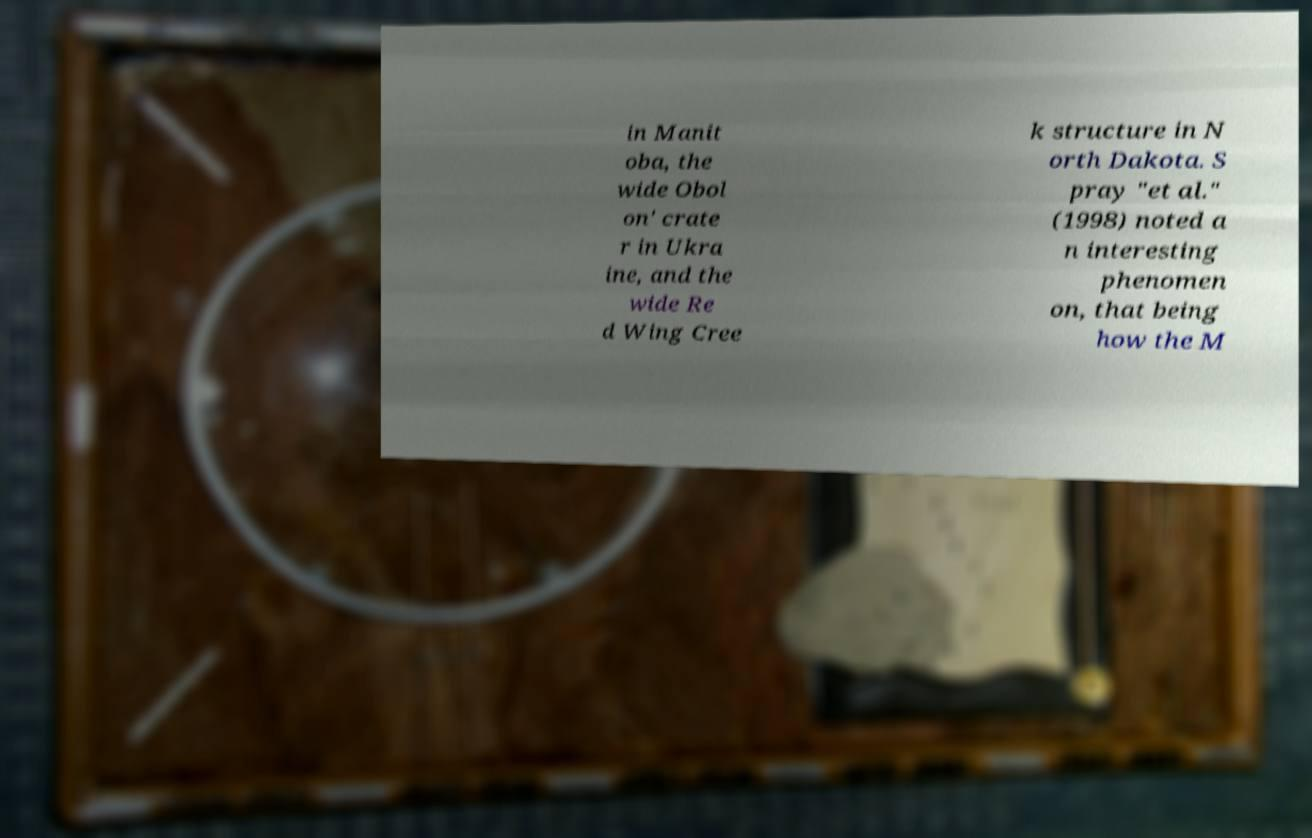Please identify and transcribe the text found in this image. in Manit oba, the wide Obol on' crate r in Ukra ine, and the wide Re d Wing Cree k structure in N orth Dakota. S pray "et al." (1998) noted a n interesting phenomen on, that being how the M 